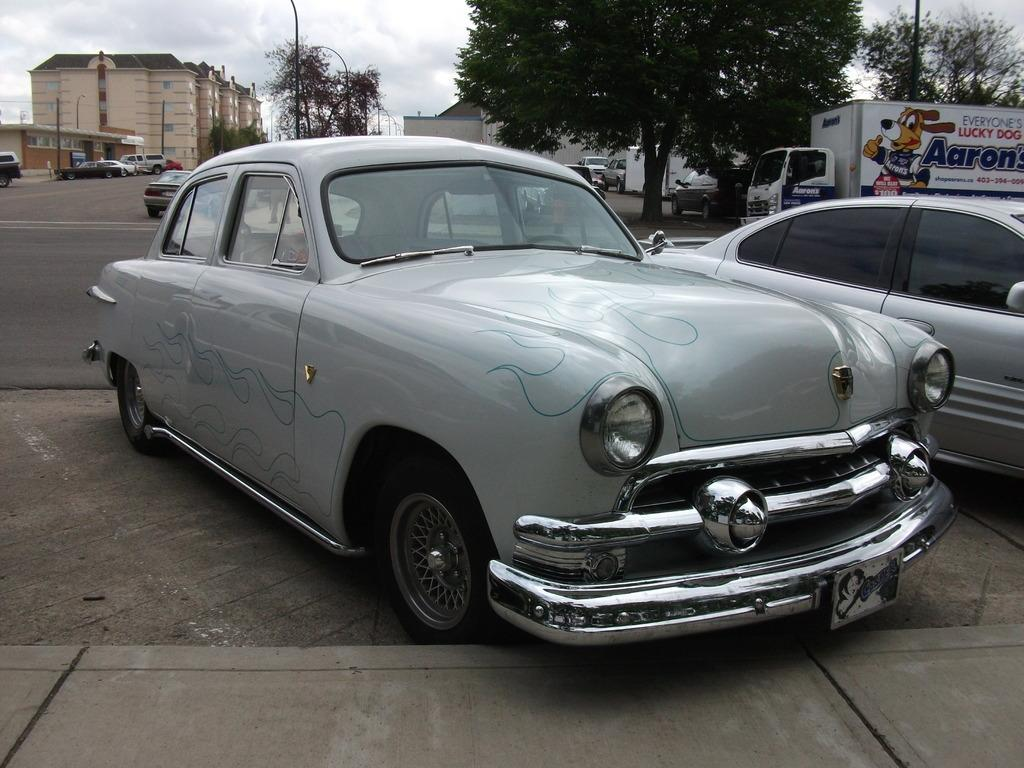What type of vehicles can be seen in the image? There are many cars in the image. Can you describe the van in the image? There is a van on the right side of the image. What is located behind the van? There are trees behind the van. What type of structures are on the left side of the image? There are buildings on the left side of the image. What type of oatmeal is being served with a spoon in the image? There is no oatmeal or spoon present in the image. What is the mysterious "thing" that can be seen in the image? There is no "thing" mentioned in the provided facts, and the image only contains cars, a van, trees, and buildings. 